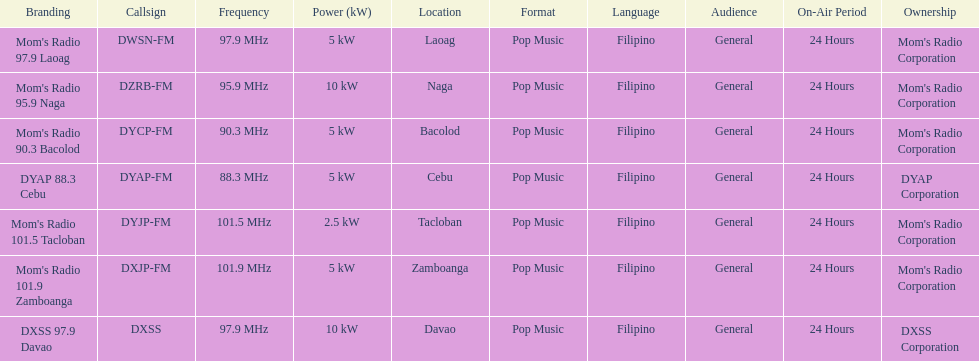How many kw was the radio in davao? 10 kW. 